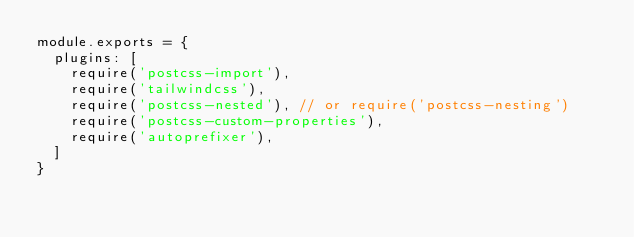<code> <loc_0><loc_0><loc_500><loc_500><_JavaScript_>module.exports = {
  plugins: [
    require('postcss-import'),
    require('tailwindcss'),
    require('postcss-nested'), // or require('postcss-nesting')
    require('postcss-custom-properties'),
    require('autoprefixer'),
  ]
}
</code> 